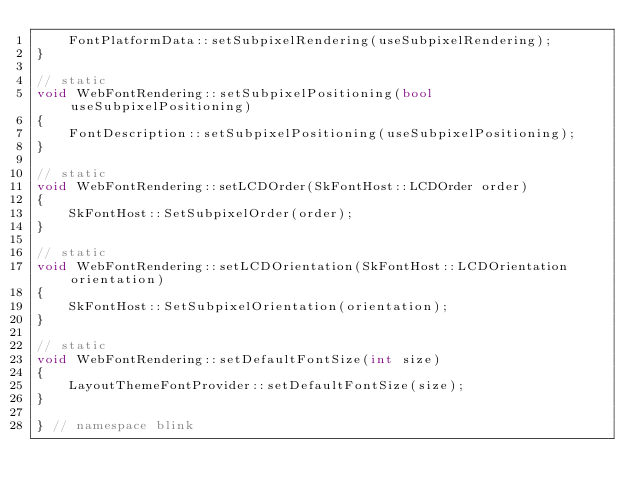<code> <loc_0><loc_0><loc_500><loc_500><_C++_>    FontPlatformData::setSubpixelRendering(useSubpixelRendering);
}

// static
void WebFontRendering::setSubpixelPositioning(bool useSubpixelPositioning)
{
    FontDescription::setSubpixelPositioning(useSubpixelPositioning);
}

// static
void WebFontRendering::setLCDOrder(SkFontHost::LCDOrder order)
{
    SkFontHost::SetSubpixelOrder(order);
}

// static
void WebFontRendering::setLCDOrientation(SkFontHost::LCDOrientation orientation)
{
    SkFontHost::SetSubpixelOrientation(orientation);
}

// static
void WebFontRendering::setDefaultFontSize(int size)
{
    LayoutThemeFontProvider::setDefaultFontSize(size);
}

} // namespace blink
</code> 